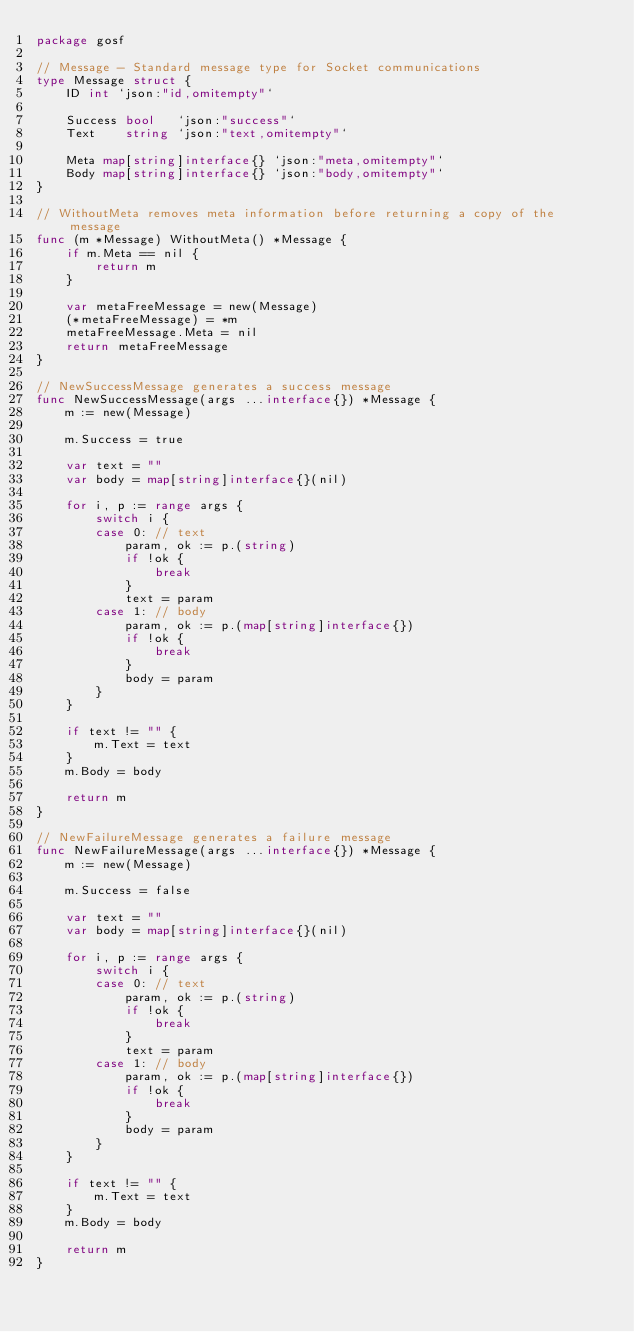Convert code to text. <code><loc_0><loc_0><loc_500><loc_500><_Go_>package gosf

// Message - Standard message type for Socket communications
type Message struct {
	ID int `json:"id,omitempty"`

	Success bool   `json:"success"`
	Text    string `json:"text,omitempty"`

	Meta map[string]interface{} `json:"meta,omitempty"`
	Body map[string]interface{} `json:"body,omitempty"`
}

// WithoutMeta removes meta information before returning a copy of the message
func (m *Message) WithoutMeta() *Message {
	if m.Meta == nil {
		return m
	}

	var metaFreeMessage = new(Message)
	(*metaFreeMessage) = *m
	metaFreeMessage.Meta = nil
	return metaFreeMessage
}

// NewSuccessMessage generates a success message
func NewSuccessMessage(args ...interface{}) *Message {
	m := new(Message)

	m.Success = true

	var text = ""
	var body = map[string]interface{}(nil)

	for i, p := range args {
		switch i {
		case 0: // text
			param, ok := p.(string)
			if !ok {
				break
			}
			text = param
		case 1: // body
			param, ok := p.(map[string]interface{})
			if !ok {
				break
			}
			body = param
		}
	}

	if text != "" {
		m.Text = text
	}
	m.Body = body

	return m
}

// NewFailureMessage generates a failure message
func NewFailureMessage(args ...interface{}) *Message {
	m := new(Message)

	m.Success = false

	var text = ""
	var body = map[string]interface{}(nil)

	for i, p := range args {
		switch i {
		case 0: // text
			param, ok := p.(string)
			if !ok {
				break
			}
			text = param
		case 1: // body
			param, ok := p.(map[string]interface{})
			if !ok {
				break
			}
			body = param
		}
	}

	if text != "" {
		m.Text = text
	}
	m.Body = body

	return m
}
</code> 